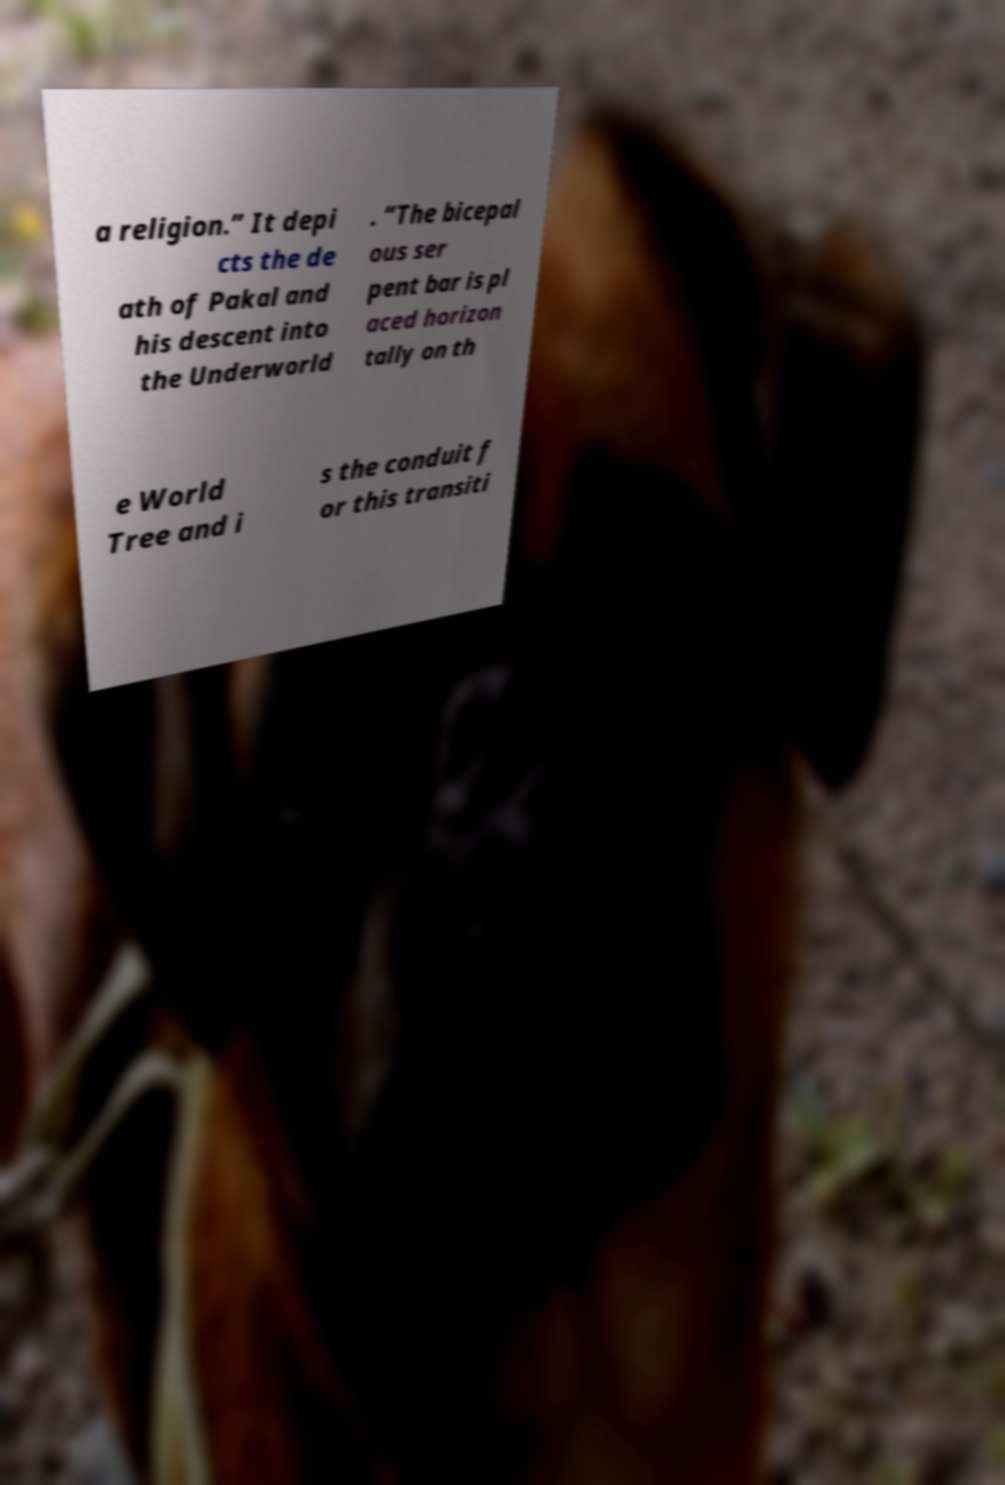Can you accurately transcribe the text from the provided image for me? a religion.” It depi cts the de ath of Pakal and his descent into the Underworld . “The bicepal ous ser pent bar is pl aced horizon tally on th e World Tree and i s the conduit f or this transiti 